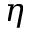<formula> <loc_0><loc_0><loc_500><loc_500>\eta</formula> 